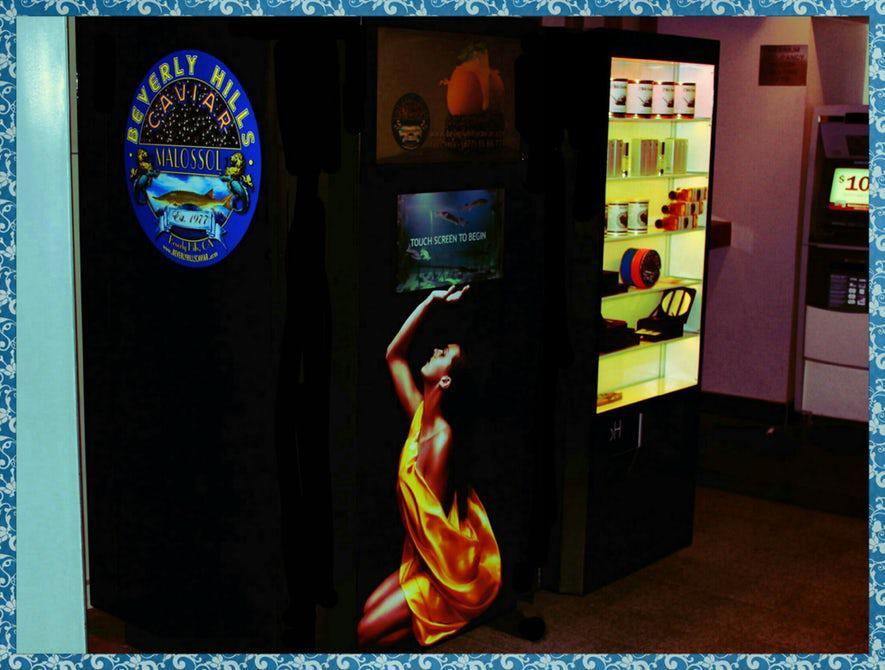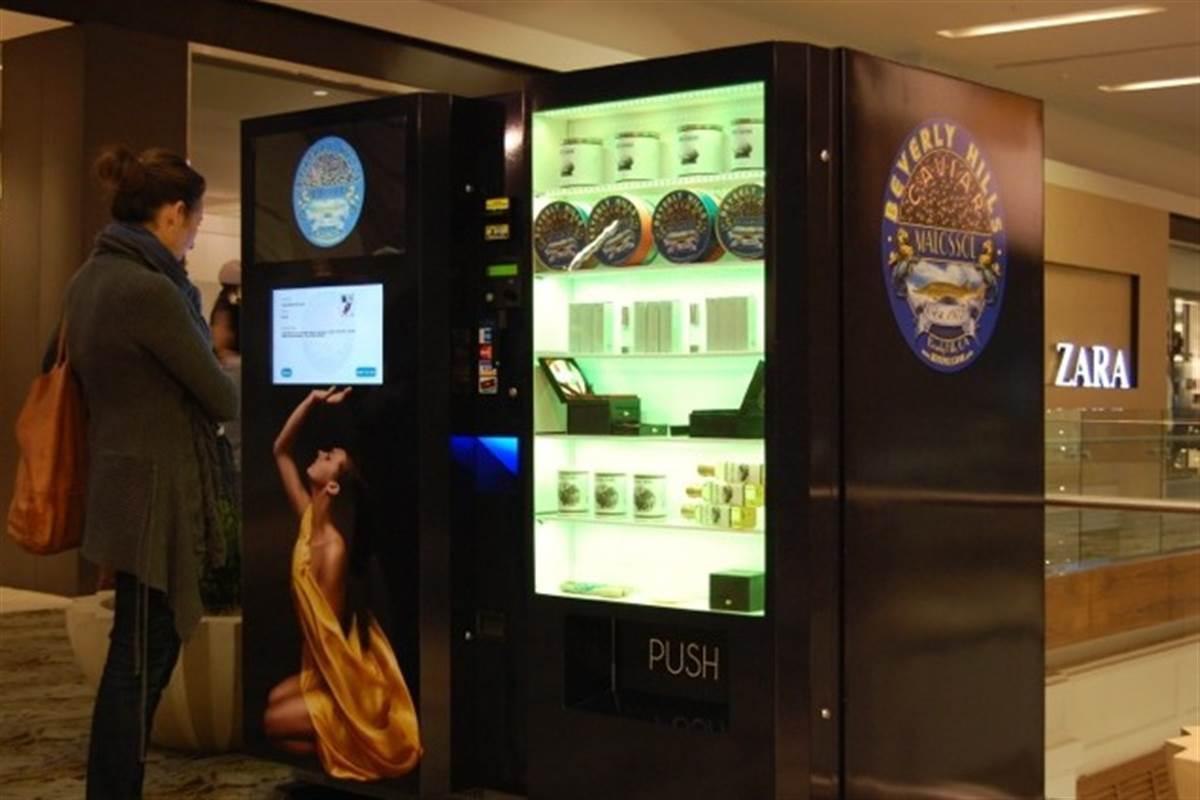The first image is the image on the left, the second image is the image on the right. Examine the images to the left and right. Is the description "A person is standing directly in front of a vending machine decorated with a woman's image, in one picture." accurate? Answer yes or no. Yes. The first image is the image on the left, the second image is the image on the right. Analyze the images presented: Is the assertion "The right image has at least one human facing towards the right in front of a vending machine." valid? Answer yes or no. Yes. 